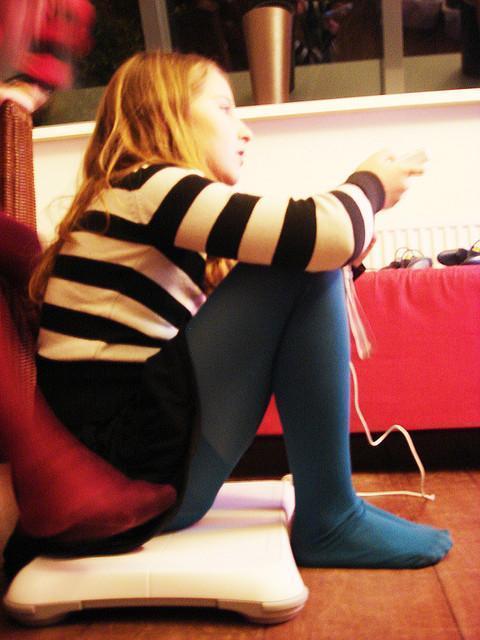How many colors are on her shirt?
Give a very brief answer. 2. How many vases are there?
Give a very brief answer. 1. How many boats are to the right of the stop sign?
Give a very brief answer. 0. 